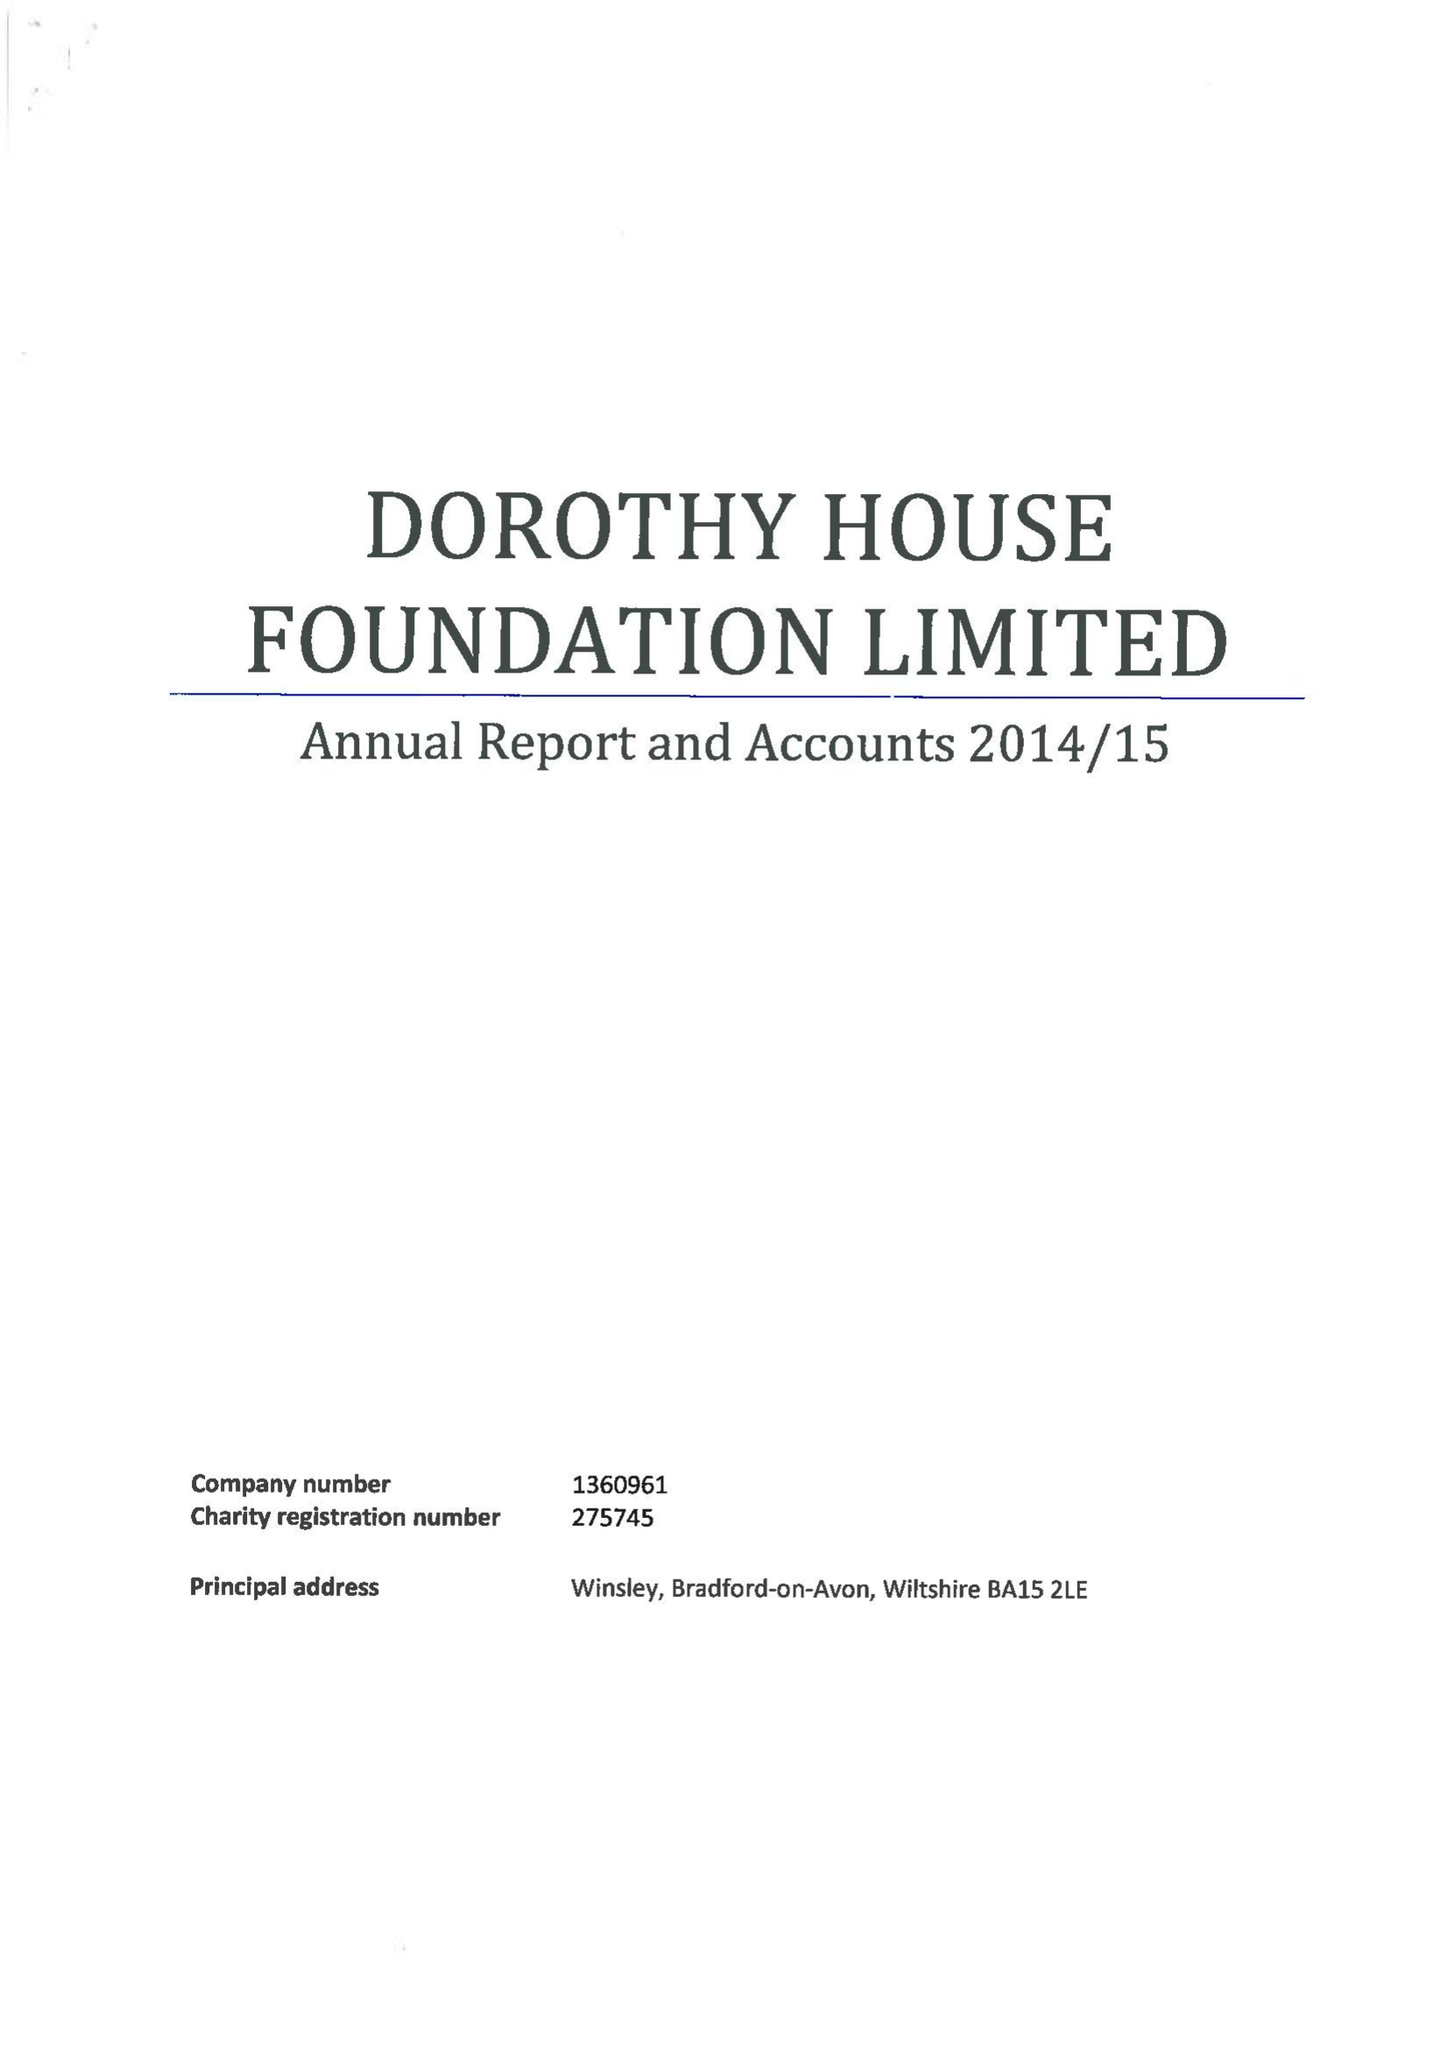What is the value for the address__postcode?
Answer the question using a single word or phrase. BA15 2LE 